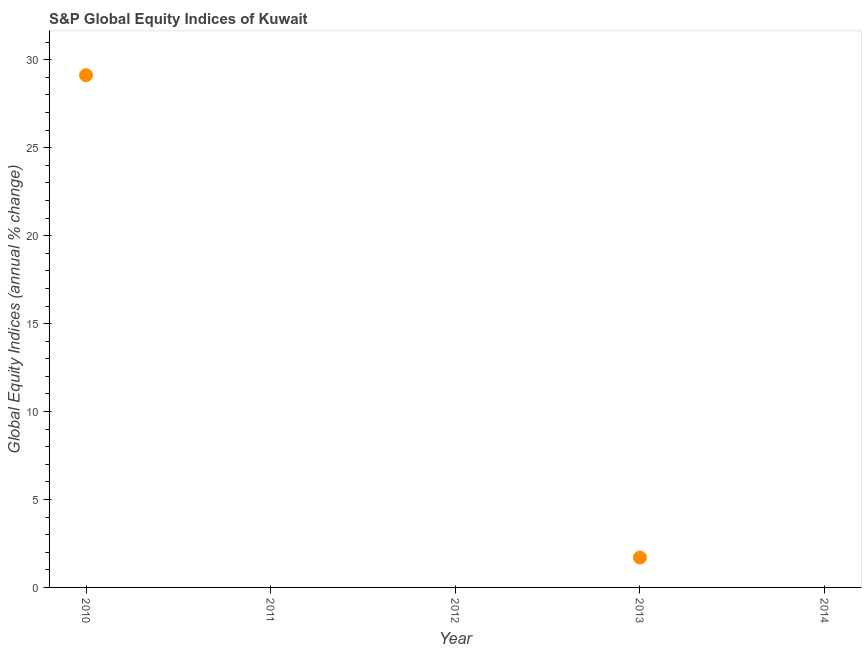What is the s&p global equity indices in 2013?
Provide a succinct answer. 1.7. Across all years, what is the maximum s&p global equity indices?
Your answer should be very brief. 29.12. What is the sum of the s&p global equity indices?
Your response must be concise. 30.82. What is the difference between the s&p global equity indices in 2010 and 2013?
Give a very brief answer. 27.43. What is the average s&p global equity indices per year?
Your answer should be compact. 6.16. What is the ratio of the s&p global equity indices in 2010 to that in 2013?
Your answer should be compact. 17.15. Is the difference between the s&p global equity indices in 2010 and 2013 greater than the difference between any two years?
Offer a terse response. No. What is the difference between the highest and the lowest s&p global equity indices?
Make the answer very short. 29.12. In how many years, is the s&p global equity indices greater than the average s&p global equity indices taken over all years?
Make the answer very short. 1. Are the values on the major ticks of Y-axis written in scientific E-notation?
Offer a very short reply. No. What is the title of the graph?
Your response must be concise. S&P Global Equity Indices of Kuwait. What is the label or title of the Y-axis?
Provide a succinct answer. Global Equity Indices (annual % change). What is the Global Equity Indices (annual % change) in 2010?
Give a very brief answer. 29.12. What is the Global Equity Indices (annual % change) in 2013?
Offer a very short reply. 1.7. What is the difference between the Global Equity Indices (annual % change) in 2010 and 2013?
Your answer should be compact. 27.43. What is the ratio of the Global Equity Indices (annual % change) in 2010 to that in 2013?
Your response must be concise. 17.15. 